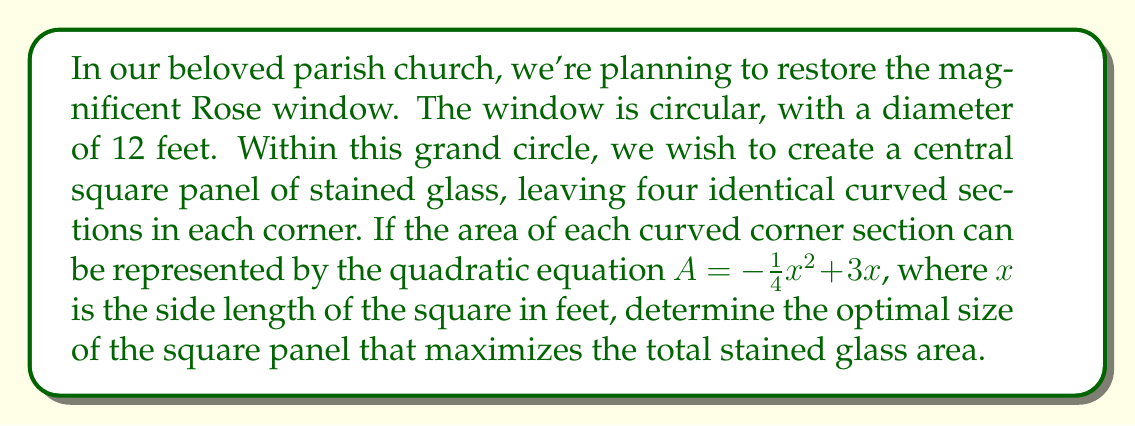Teach me how to tackle this problem. Let's approach this step-by-step:

1) The total area of the circular window is:
   $$A_{circle} = \pi r^2 = \pi (6^2) = 36\pi \approx 113.10 \text{ sq ft}$$

2) Let $x$ be the side length of the square panel. The area of the square is:
   $$A_{square} = x^2$$

3) The area of each curved corner section is given by:
   $$A_{corner} = -\frac{1}{4}x^2 + 3x$$

4) There are four corner sections, so the total area of the corners is:
   $$A_{total corners} = 4(-\frac{1}{4}x^2 + 3x) = -x^2 + 12x$$

5) The total stained glass area is the sum of the square and the corners:
   $$A_{total} = x^2 + (-x^2 + 12x) = 12x$$

6) To maximize this area, we need to find the maximum value of $12x$ where $0 \leq x \leq 12$ (as the square can't be larger than the circle's diameter).

7) Since this is a linear function, the maximum will occur at one of the endpoints. Let's evaluate:
   At $x = 0$: $A_{total} = 12(0) = 0$
   At $x = 12$: $A_{total} = 12(12) = 144$

Therefore, the maximum stained glass area occurs when the square panel has a side length of 12 feet, which is the full diameter of the circular window.
Answer: 12 feet 